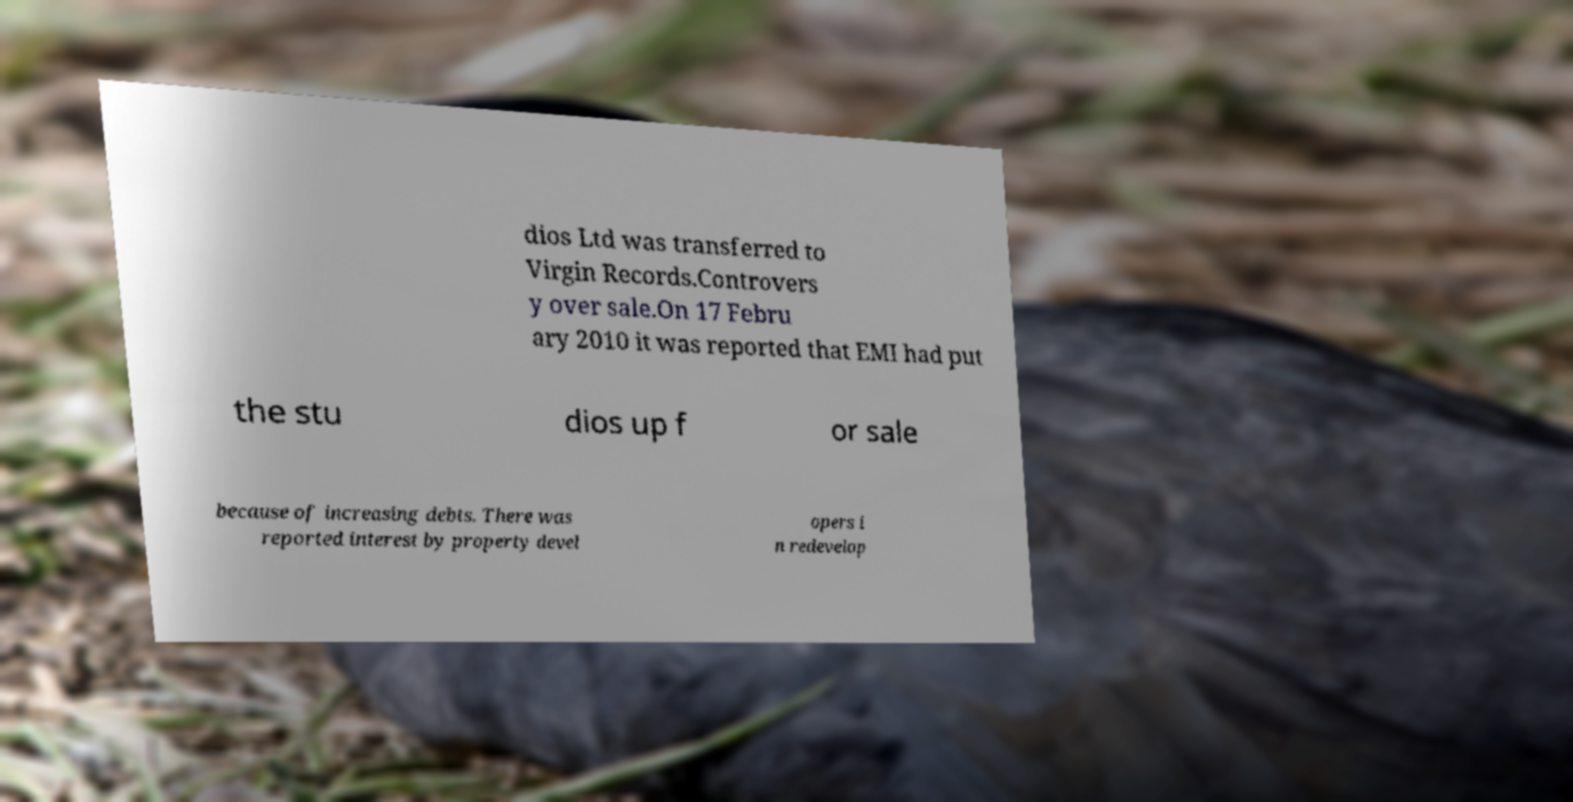Could you assist in decoding the text presented in this image and type it out clearly? dios Ltd was transferred to Virgin Records.Controvers y over sale.On 17 Febru ary 2010 it was reported that EMI had put the stu dios up f or sale because of increasing debts. There was reported interest by property devel opers i n redevelop 